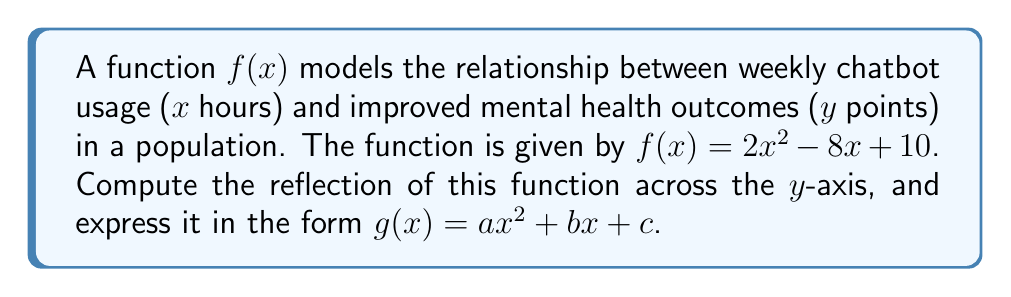Provide a solution to this math problem. To reflect a function across the y-axis, we replace every x with -x in the original function. Let's go through this step-by-step:

1) The original function is $f(x) = 2x^2 - 8x + 10$

2) Replace every x with -x:
   $g(x) = 2(-x)^2 - 8(-x) + 10$

3) Simplify:
   $g(x) = 2x^2 + 8x + 10$

   Note that:
   - $(-x)^2 = x^2$ because any number squared is positive
   - $-8(-x) = 8x$ because the negatives cancel out

4) The reflected function is now in the form $g(x) = ax^2 + bx + c$, where:
   $a = 2$
   $b = 8$
   $c = 10$

This reflection shows how the relationship between chatbot usage and mental health outcomes would change if we considered negative usage (which doesn't have a real-world interpretation but is mathematically valid).
Answer: $g(x) = 2x^2 + 8x + 10$ 